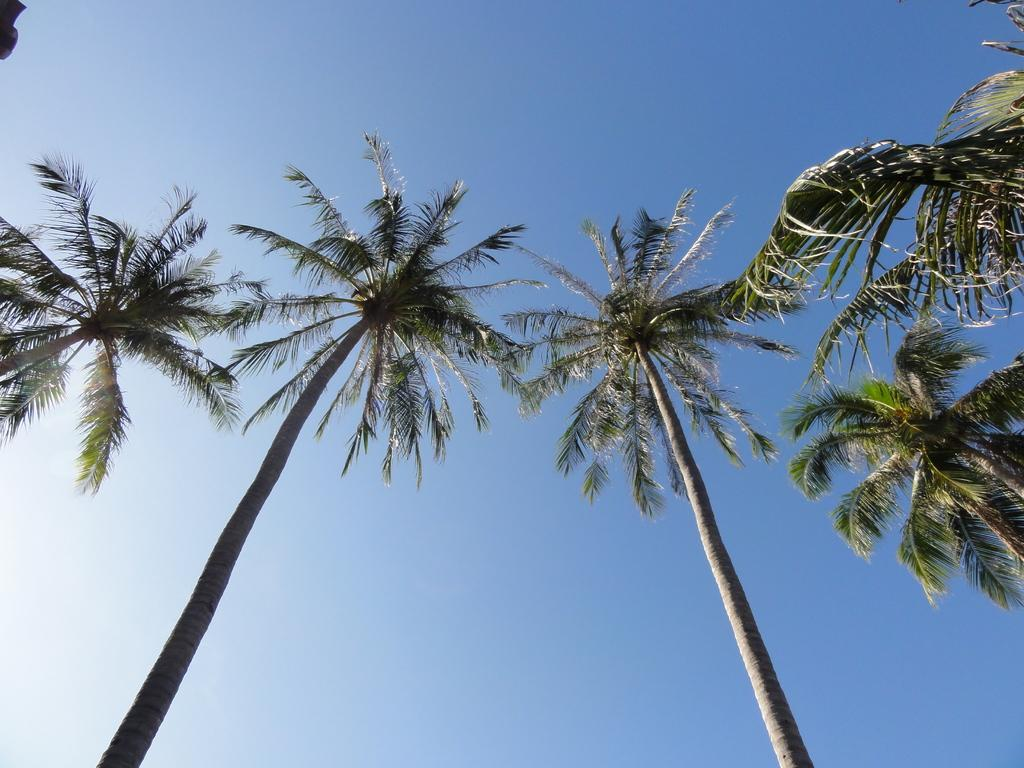What type of vegetation can be seen in the image? There are trees present in the image. Can you describe the trees in the image? The trees in the image are tall and have green leaves. What is the setting of the image? The image appears to be set in a natural environment, given the presence of trees. What type of knife can be seen cutting through the tree in the image? There is no knife present in the image, nor is there any indication of a tree being cut. 